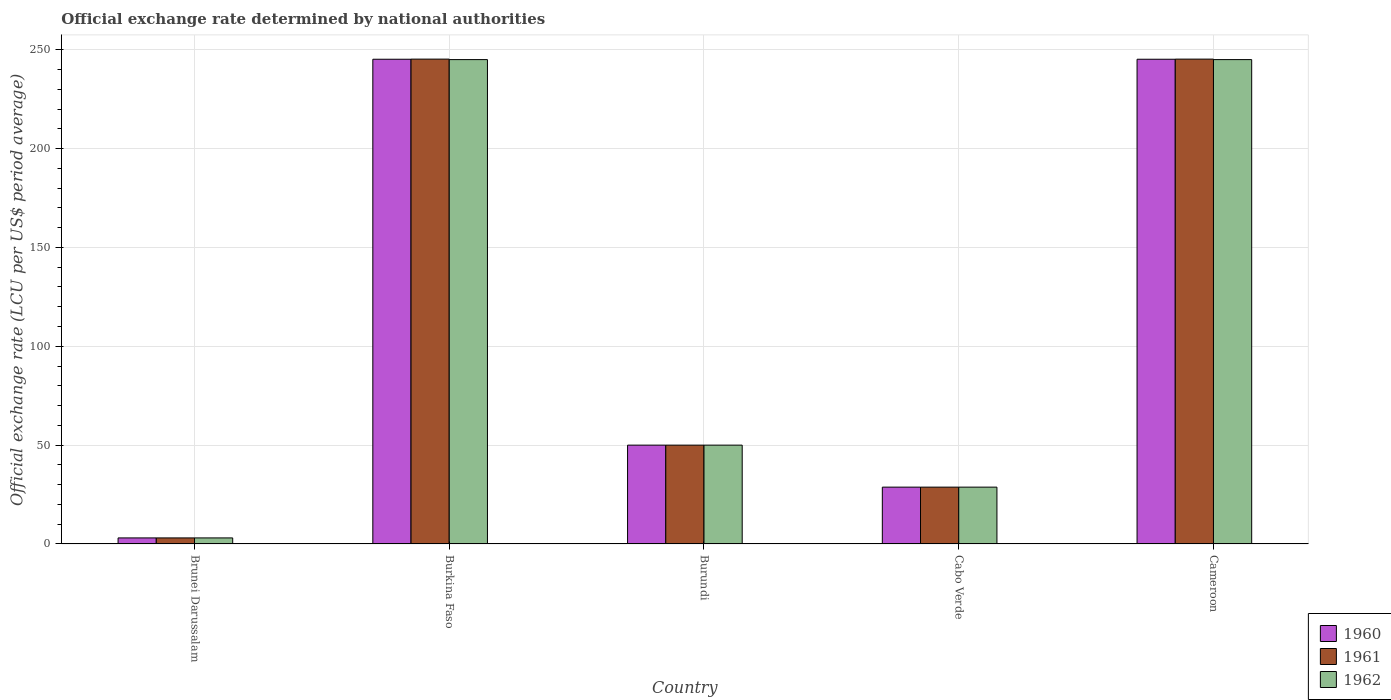How many different coloured bars are there?
Give a very brief answer. 3. How many bars are there on the 3rd tick from the left?
Your answer should be compact. 3. How many bars are there on the 4th tick from the right?
Your answer should be compact. 3. What is the label of the 1st group of bars from the left?
Make the answer very short. Brunei Darussalam. In how many cases, is the number of bars for a given country not equal to the number of legend labels?
Give a very brief answer. 0. What is the official exchange rate in 1960 in Cameroon?
Your answer should be compact. 245.2. Across all countries, what is the maximum official exchange rate in 1960?
Provide a succinct answer. 245.2. Across all countries, what is the minimum official exchange rate in 1962?
Your answer should be compact. 3.06. In which country was the official exchange rate in 1961 maximum?
Provide a succinct answer. Burkina Faso. In which country was the official exchange rate in 1960 minimum?
Provide a succinct answer. Brunei Darussalam. What is the total official exchange rate in 1961 in the graph?
Keep it short and to the point. 572.33. What is the difference between the official exchange rate in 1961 in Burkina Faso and that in Burundi?
Your response must be concise. 195.26. What is the difference between the official exchange rate in 1960 in Brunei Darussalam and the official exchange rate in 1962 in Cameroon?
Give a very brief answer. -241.95. What is the average official exchange rate in 1961 per country?
Make the answer very short. 114.47. What is the difference between the official exchange rate of/in 1961 and official exchange rate of/in 1960 in Burkina Faso?
Provide a succinct answer. 0.07. What is the ratio of the official exchange rate in 1960 in Burundi to that in Cabo Verde?
Your answer should be compact. 1.74. Is the official exchange rate in 1961 in Brunei Darussalam less than that in Cameroon?
Your response must be concise. Yes. What is the difference between the highest and the second highest official exchange rate in 1960?
Provide a succinct answer. -195.2. What is the difference between the highest and the lowest official exchange rate in 1961?
Your response must be concise. 242.2. In how many countries, is the official exchange rate in 1962 greater than the average official exchange rate in 1962 taken over all countries?
Make the answer very short. 2. Is the sum of the official exchange rate in 1962 in Brunei Darussalam and Cameroon greater than the maximum official exchange rate in 1960 across all countries?
Your answer should be very brief. Yes. What does the 1st bar from the left in Cabo Verde represents?
Keep it short and to the point. 1960. What does the 2nd bar from the right in Cameroon represents?
Ensure brevity in your answer.  1961. How many bars are there?
Keep it short and to the point. 15. Are all the bars in the graph horizontal?
Your answer should be compact. No. How many countries are there in the graph?
Offer a very short reply. 5. Are the values on the major ticks of Y-axis written in scientific E-notation?
Make the answer very short. No. Does the graph contain grids?
Your response must be concise. Yes. What is the title of the graph?
Keep it short and to the point. Official exchange rate determined by national authorities. Does "1996" appear as one of the legend labels in the graph?
Offer a terse response. No. What is the label or title of the Y-axis?
Keep it short and to the point. Official exchange rate (LCU per US$ period average). What is the Official exchange rate (LCU per US$ period average) in 1960 in Brunei Darussalam?
Provide a succinct answer. 3.06. What is the Official exchange rate (LCU per US$ period average) in 1961 in Brunei Darussalam?
Your answer should be compact. 3.06. What is the Official exchange rate (LCU per US$ period average) in 1962 in Brunei Darussalam?
Offer a terse response. 3.06. What is the Official exchange rate (LCU per US$ period average) in 1960 in Burkina Faso?
Keep it short and to the point. 245.2. What is the Official exchange rate (LCU per US$ period average) in 1961 in Burkina Faso?
Your answer should be very brief. 245.26. What is the Official exchange rate (LCU per US$ period average) in 1962 in Burkina Faso?
Offer a very short reply. 245.01. What is the Official exchange rate (LCU per US$ period average) of 1960 in Burundi?
Offer a very short reply. 50. What is the Official exchange rate (LCU per US$ period average) in 1961 in Burundi?
Your answer should be compact. 50. What is the Official exchange rate (LCU per US$ period average) of 1962 in Burundi?
Offer a very short reply. 50. What is the Official exchange rate (LCU per US$ period average) in 1960 in Cabo Verde?
Make the answer very short. 28.75. What is the Official exchange rate (LCU per US$ period average) in 1961 in Cabo Verde?
Your response must be concise. 28.75. What is the Official exchange rate (LCU per US$ period average) of 1962 in Cabo Verde?
Ensure brevity in your answer.  28.75. What is the Official exchange rate (LCU per US$ period average) in 1960 in Cameroon?
Make the answer very short. 245.2. What is the Official exchange rate (LCU per US$ period average) in 1961 in Cameroon?
Offer a very short reply. 245.26. What is the Official exchange rate (LCU per US$ period average) of 1962 in Cameroon?
Your response must be concise. 245.01. Across all countries, what is the maximum Official exchange rate (LCU per US$ period average) of 1960?
Make the answer very short. 245.2. Across all countries, what is the maximum Official exchange rate (LCU per US$ period average) in 1961?
Provide a short and direct response. 245.26. Across all countries, what is the maximum Official exchange rate (LCU per US$ period average) in 1962?
Provide a short and direct response. 245.01. Across all countries, what is the minimum Official exchange rate (LCU per US$ period average) in 1960?
Make the answer very short. 3.06. Across all countries, what is the minimum Official exchange rate (LCU per US$ period average) of 1961?
Offer a very short reply. 3.06. Across all countries, what is the minimum Official exchange rate (LCU per US$ period average) in 1962?
Provide a short and direct response. 3.06. What is the total Official exchange rate (LCU per US$ period average) in 1960 in the graph?
Keep it short and to the point. 572.2. What is the total Official exchange rate (LCU per US$ period average) of 1961 in the graph?
Ensure brevity in your answer.  572.33. What is the total Official exchange rate (LCU per US$ period average) of 1962 in the graph?
Offer a terse response. 571.84. What is the difference between the Official exchange rate (LCU per US$ period average) in 1960 in Brunei Darussalam and that in Burkina Faso?
Offer a very short reply. -242.13. What is the difference between the Official exchange rate (LCU per US$ period average) in 1961 in Brunei Darussalam and that in Burkina Faso?
Provide a succinct answer. -242.2. What is the difference between the Official exchange rate (LCU per US$ period average) in 1962 in Brunei Darussalam and that in Burkina Faso?
Your response must be concise. -241.95. What is the difference between the Official exchange rate (LCU per US$ period average) of 1960 in Brunei Darussalam and that in Burundi?
Ensure brevity in your answer.  -46.94. What is the difference between the Official exchange rate (LCU per US$ period average) in 1961 in Brunei Darussalam and that in Burundi?
Keep it short and to the point. -46.94. What is the difference between the Official exchange rate (LCU per US$ period average) of 1962 in Brunei Darussalam and that in Burundi?
Provide a succinct answer. -46.94. What is the difference between the Official exchange rate (LCU per US$ period average) of 1960 in Brunei Darussalam and that in Cabo Verde?
Provide a succinct answer. -25.69. What is the difference between the Official exchange rate (LCU per US$ period average) in 1961 in Brunei Darussalam and that in Cabo Verde?
Your answer should be compact. -25.69. What is the difference between the Official exchange rate (LCU per US$ period average) in 1962 in Brunei Darussalam and that in Cabo Verde?
Ensure brevity in your answer.  -25.69. What is the difference between the Official exchange rate (LCU per US$ period average) of 1960 in Brunei Darussalam and that in Cameroon?
Your answer should be compact. -242.13. What is the difference between the Official exchange rate (LCU per US$ period average) of 1961 in Brunei Darussalam and that in Cameroon?
Make the answer very short. -242.2. What is the difference between the Official exchange rate (LCU per US$ period average) in 1962 in Brunei Darussalam and that in Cameroon?
Your answer should be very brief. -241.95. What is the difference between the Official exchange rate (LCU per US$ period average) in 1960 in Burkina Faso and that in Burundi?
Provide a succinct answer. 195.2. What is the difference between the Official exchange rate (LCU per US$ period average) in 1961 in Burkina Faso and that in Burundi?
Ensure brevity in your answer.  195.26. What is the difference between the Official exchange rate (LCU per US$ period average) in 1962 in Burkina Faso and that in Burundi?
Make the answer very short. 195.01. What is the difference between the Official exchange rate (LCU per US$ period average) of 1960 in Burkina Faso and that in Cabo Verde?
Ensure brevity in your answer.  216.45. What is the difference between the Official exchange rate (LCU per US$ period average) of 1961 in Burkina Faso and that in Cabo Verde?
Keep it short and to the point. 216.51. What is the difference between the Official exchange rate (LCU per US$ period average) in 1962 in Burkina Faso and that in Cabo Verde?
Offer a terse response. 216.26. What is the difference between the Official exchange rate (LCU per US$ period average) in 1961 in Burkina Faso and that in Cameroon?
Offer a very short reply. 0. What is the difference between the Official exchange rate (LCU per US$ period average) of 1962 in Burkina Faso and that in Cameroon?
Keep it short and to the point. 0. What is the difference between the Official exchange rate (LCU per US$ period average) of 1960 in Burundi and that in Cabo Verde?
Your response must be concise. 21.25. What is the difference between the Official exchange rate (LCU per US$ period average) in 1961 in Burundi and that in Cabo Verde?
Provide a short and direct response. 21.25. What is the difference between the Official exchange rate (LCU per US$ period average) of 1962 in Burundi and that in Cabo Verde?
Give a very brief answer. 21.25. What is the difference between the Official exchange rate (LCU per US$ period average) of 1960 in Burundi and that in Cameroon?
Provide a short and direct response. -195.2. What is the difference between the Official exchange rate (LCU per US$ period average) in 1961 in Burundi and that in Cameroon?
Make the answer very short. -195.26. What is the difference between the Official exchange rate (LCU per US$ period average) of 1962 in Burundi and that in Cameroon?
Offer a very short reply. -195.01. What is the difference between the Official exchange rate (LCU per US$ period average) in 1960 in Cabo Verde and that in Cameroon?
Your response must be concise. -216.45. What is the difference between the Official exchange rate (LCU per US$ period average) in 1961 in Cabo Verde and that in Cameroon?
Provide a succinct answer. -216.51. What is the difference between the Official exchange rate (LCU per US$ period average) of 1962 in Cabo Verde and that in Cameroon?
Your response must be concise. -216.26. What is the difference between the Official exchange rate (LCU per US$ period average) of 1960 in Brunei Darussalam and the Official exchange rate (LCU per US$ period average) of 1961 in Burkina Faso?
Offer a terse response. -242.2. What is the difference between the Official exchange rate (LCU per US$ period average) in 1960 in Brunei Darussalam and the Official exchange rate (LCU per US$ period average) in 1962 in Burkina Faso?
Provide a short and direct response. -241.95. What is the difference between the Official exchange rate (LCU per US$ period average) in 1961 in Brunei Darussalam and the Official exchange rate (LCU per US$ period average) in 1962 in Burkina Faso?
Keep it short and to the point. -241.95. What is the difference between the Official exchange rate (LCU per US$ period average) in 1960 in Brunei Darussalam and the Official exchange rate (LCU per US$ period average) in 1961 in Burundi?
Your response must be concise. -46.94. What is the difference between the Official exchange rate (LCU per US$ period average) of 1960 in Brunei Darussalam and the Official exchange rate (LCU per US$ period average) of 1962 in Burundi?
Ensure brevity in your answer.  -46.94. What is the difference between the Official exchange rate (LCU per US$ period average) of 1961 in Brunei Darussalam and the Official exchange rate (LCU per US$ period average) of 1962 in Burundi?
Your answer should be very brief. -46.94. What is the difference between the Official exchange rate (LCU per US$ period average) of 1960 in Brunei Darussalam and the Official exchange rate (LCU per US$ period average) of 1961 in Cabo Verde?
Offer a very short reply. -25.69. What is the difference between the Official exchange rate (LCU per US$ period average) of 1960 in Brunei Darussalam and the Official exchange rate (LCU per US$ period average) of 1962 in Cabo Verde?
Keep it short and to the point. -25.69. What is the difference between the Official exchange rate (LCU per US$ period average) in 1961 in Brunei Darussalam and the Official exchange rate (LCU per US$ period average) in 1962 in Cabo Verde?
Offer a very short reply. -25.69. What is the difference between the Official exchange rate (LCU per US$ period average) in 1960 in Brunei Darussalam and the Official exchange rate (LCU per US$ period average) in 1961 in Cameroon?
Provide a short and direct response. -242.2. What is the difference between the Official exchange rate (LCU per US$ period average) of 1960 in Brunei Darussalam and the Official exchange rate (LCU per US$ period average) of 1962 in Cameroon?
Provide a succinct answer. -241.95. What is the difference between the Official exchange rate (LCU per US$ period average) of 1961 in Brunei Darussalam and the Official exchange rate (LCU per US$ period average) of 1962 in Cameroon?
Make the answer very short. -241.95. What is the difference between the Official exchange rate (LCU per US$ period average) in 1960 in Burkina Faso and the Official exchange rate (LCU per US$ period average) in 1961 in Burundi?
Your answer should be compact. 195.2. What is the difference between the Official exchange rate (LCU per US$ period average) in 1960 in Burkina Faso and the Official exchange rate (LCU per US$ period average) in 1962 in Burundi?
Provide a short and direct response. 195.2. What is the difference between the Official exchange rate (LCU per US$ period average) in 1961 in Burkina Faso and the Official exchange rate (LCU per US$ period average) in 1962 in Burundi?
Offer a terse response. 195.26. What is the difference between the Official exchange rate (LCU per US$ period average) in 1960 in Burkina Faso and the Official exchange rate (LCU per US$ period average) in 1961 in Cabo Verde?
Your answer should be compact. 216.45. What is the difference between the Official exchange rate (LCU per US$ period average) of 1960 in Burkina Faso and the Official exchange rate (LCU per US$ period average) of 1962 in Cabo Verde?
Your response must be concise. 216.45. What is the difference between the Official exchange rate (LCU per US$ period average) in 1961 in Burkina Faso and the Official exchange rate (LCU per US$ period average) in 1962 in Cabo Verde?
Your answer should be very brief. 216.51. What is the difference between the Official exchange rate (LCU per US$ period average) of 1960 in Burkina Faso and the Official exchange rate (LCU per US$ period average) of 1961 in Cameroon?
Ensure brevity in your answer.  -0.07. What is the difference between the Official exchange rate (LCU per US$ period average) of 1960 in Burkina Faso and the Official exchange rate (LCU per US$ period average) of 1962 in Cameroon?
Offer a terse response. 0.18. What is the difference between the Official exchange rate (LCU per US$ period average) in 1961 in Burkina Faso and the Official exchange rate (LCU per US$ period average) in 1962 in Cameroon?
Offer a very short reply. 0.25. What is the difference between the Official exchange rate (LCU per US$ period average) of 1960 in Burundi and the Official exchange rate (LCU per US$ period average) of 1961 in Cabo Verde?
Give a very brief answer. 21.25. What is the difference between the Official exchange rate (LCU per US$ period average) of 1960 in Burundi and the Official exchange rate (LCU per US$ period average) of 1962 in Cabo Verde?
Offer a terse response. 21.25. What is the difference between the Official exchange rate (LCU per US$ period average) in 1961 in Burundi and the Official exchange rate (LCU per US$ period average) in 1962 in Cabo Verde?
Provide a short and direct response. 21.25. What is the difference between the Official exchange rate (LCU per US$ period average) in 1960 in Burundi and the Official exchange rate (LCU per US$ period average) in 1961 in Cameroon?
Keep it short and to the point. -195.26. What is the difference between the Official exchange rate (LCU per US$ period average) in 1960 in Burundi and the Official exchange rate (LCU per US$ period average) in 1962 in Cameroon?
Offer a very short reply. -195.01. What is the difference between the Official exchange rate (LCU per US$ period average) in 1961 in Burundi and the Official exchange rate (LCU per US$ period average) in 1962 in Cameroon?
Make the answer very short. -195.01. What is the difference between the Official exchange rate (LCU per US$ period average) in 1960 in Cabo Verde and the Official exchange rate (LCU per US$ period average) in 1961 in Cameroon?
Your answer should be compact. -216.51. What is the difference between the Official exchange rate (LCU per US$ period average) of 1960 in Cabo Verde and the Official exchange rate (LCU per US$ period average) of 1962 in Cameroon?
Provide a short and direct response. -216.26. What is the difference between the Official exchange rate (LCU per US$ period average) in 1961 in Cabo Verde and the Official exchange rate (LCU per US$ period average) in 1962 in Cameroon?
Provide a short and direct response. -216.26. What is the average Official exchange rate (LCU per US$ period average) in 1960 per country?
Make the answer very short. 114.44. What is the average Official exchange rate (LCU per US$ period average) of 1961 per country?
Provide a short and direct response. 114.47. What is the average Official exchange rate (LCU per US$ period average) of 1962 per country?
Give a very brief answer. 114.37. What is the difference between the Official exchange rate (LCU per US$ period average) in 1960 and Official exchange rate (LCU per US$ period average) in 1961 in Brunei Darussalam?
Offer a terse response. 0. What is the difference between the Official exchange rate (LCU per US$ period average) of 1960 and Official exchange rate (LCU per US$ period average) of 1962 in Brunei Darussalam?
Offer a very short reply. 0. What is the difference between the Official exchange rate (LCU per US$ period average) of 1961 and Official exchange rate (LCU per US$ period average) of 1962 in Brunei Darussalam?
Give a very brief answer. 0. What is the difference between the Official exchange rate (LCU per US$ period average) in 1960 and Official exchange rate (LCU per US$ period average) in 1961 in Burkina Faso?
Provide a succinct answer. -0.07. What is the difference between the Official exchange rate (LCU per US$ period average) in 1960 and Official exchange rate (LCU per US$ period average) in 1962 in Burkina Faso?
Your answer should be compact. 0.18. What is the difference between the Official exchange rate (LCU per US$ period average) of 1961 and Official exchange rate (LCU per US$ period average) of 1962 in Burkina Faso?
Keep it short and to the point. 0.25. What is the difference between the Official exchange rate (LCU per US$ period average) in 1960 and Official exchange rate (LCU per US$ period average) in 1961 in Burundi?
Offer a very short reply. 0. What is the difference between the Official exchange rate (LCU per US$ period average) in 1960 and Official exchange rate (LCU per US$ period average) in 1962 in Burundi?
Offer a very short reply. 0. What is the difference between the Official exchange rate (LCU per US$ period average) in 1961 and Official exchange rate (LCU per US$ period average) in 1962 in Burundi?
Ensure brevity in your answer.  0. What is the difference between the Official exchange rate (LCU per US$ period average) in 1960 and Official exchange rate (LCU per US$ period average) in 1961 in Cabo Verde?
Offer a terse response. 0. What is the difference between the Official exchange rate (LCU per US$ period average) of 1960 and Official exchange rate (LCU per US$ period average) of 1961 in Cameroon?
Offer a very short reply. -0.07. What is the difference between the Official exchange rate (LCU per US$ period average) of 1960 and Official exchange rate (LCU per US$ period average) of 1962 in Cameroon?
Your answer should be very brief. 0.18. What is the difference between the Official exchange rate (LCU per US$ period average) of 1961 and Official exchange rate (LCU per US$ period average) of 1962 in Cameroon?
Offer a terse response. 0.25. What is the ratio of the Official exchange rate (LCU per US$ period average) in 1960 in Brunei Darussalam to that in Burkina Faso?
Keep it short and to the point. 0.01. What is the ratio of the Official exchange rate (LCU per US$ period average) of 1961 in Brunei Darussalam to that in Burkina Faso?
Offer a terse response. 0.01. What is the ratio of the Official exchange rate (LCU per US$ period average) in 1962 in Brunei Darussalam to that in Burkina Faso?
Provide a succinct answer. 0.01. What is the ratio of the Official exchange rate (LCU per US$ period average) in 1960 in Brunei Darussalam to that in Burundi?
Give a very brief answer. 0.06. What is the ratio of the Official exchange rate (LCU per US$ period average) of 1961 in Brunei Darussalam to that in Burundi?
Ensure brevity in your answer.  0.06. What is the ratio of the Official exchange rate (LCU per US$ period average) in 1962 in Brunei Darussalam to that in Burundi?
Offer a terse response. 0.06. What is the ratio of the Official exchange rate (LCU per US$ period average) in 1960 in Brunei Darussalam to that in Cabo Verde?
Offer a terse response. 0.11. What is the ratio of the Official exchange rate (LCU per US$ period average) of 1961 in Brunei Darussalam to that in Cabo Verde?
Provide a short and direct response. 0.11. What is the ratio of the Official exchange rate (LCU per US$ period average) in 1962 in Brunei Darussalam to that in Cabo Verde?
Offer a terse response. 0.11. What is the ratio of the Official exchange rate (LCU per US$ period average) of 1960 in Brunei Darussalam to that in Cameroon?
Make the answer very short. 0.01. What is the ratio of the Official exchange rate (LCU per US$ period average) of 1961 in Brunei Darussalam to that in Cameroon?
Make the answer very short. 0.01. What is the ratio of the Official exchange rate (LCU per US$ period average) in 1962 in Brunei Darussalam to that in Cameroon?
Offer a very short reply. 0.01. What is the ratio of the Official exchange rate (LCU per US$ period average) in 1960 in Burkina Faso to that in Burundi?
Give a very brief answer. 4.9. What is the ratio of the Official exchange rate (LCU per US$ period average) of 1961 in Burkina Faso to that in Burundi?
Give a very brief answer. 4.91. What is the ratio of the Official exchange rate (LCU per US$ period average) in 1962 in Burkina Faso to that in Burundi?
Ensure brevity in your answer.  4.9. What is the ratio of the Official exchange rate (LCU per US$ period average) in 1960 in Burkina Faso to that in Cabo Verde?
Your response must be concise. 8.53. What is the ratio of the Official exchange rate (LCU per US$ period average) in 1961 in Burkina Faso to that in Cabo Verde?
Provide a succinct answer. 8.53. What is the ratio of the Official exchange rate (LCU per US$ period average) of 1962 in Burkina Faso to that in Cabo Verde?
Give a very brief answer. 8.52. What is the ratio of the Official exchange rate (LCU per US$ period average) in 1960 in Burkina Faso to that in Cameroon?
Make the answer very short. 1. What is the ratio of the Official exchange rate (LCU per US$ period average) in 1960 in Burundi to that in Cabo Verde?
Keep it short and to the point. 1.74. What is the ratio of the Official exchange rate (LCU per US$ period average) in 1961 in Burundi to that in Cabo Verde?
Offer a very short reply. 1.74. What is the ratio of the Official exchange rate (LCU per US$ period average) of 1962 in Burundi to that in Cabo Verde?
Your answer should be very brief. 1.74. What is the ratio of the Official exchange rate (LCU per US$ period average) of 1960 in Burundi to that in Cameroon?
Your answer should be compact. 0.2. What is the ratio of the Official exchange rate (LCU per US$ period average) of 1961 in Burundi to that in Cameroon?
Provide a short and direct response. 0.2. What is the ratio of the Official exchange rate (LCU per US$ period average) in 1962 in Burundi to that in Cameroon?
Your answer should be very brief. 0.2. What is the ratio of the Official exchange rate (LCU per US$ period average) in 1960 in Cabo Verde to that in Cameroon?
Provide a short and direct response. 0.12. What is the ratio of the Official exchange rate (LCU per US$ period average) of 1961 in Cabo Verde to that in Cameroon?
Provide a short and direct response. 0.12. What is the ratio of the Official exchange rate (LCU per US$ period average) of 1962 in Cabo Verde to that in Cameroon?
Ensure brevity in your answer.  0.12. What is the difference between the highest and the second highest Official exchange rate (LCU per US$ period average) in 1962?
Your response must be concise. 0. What is the difference between the highest and the lowest Official exchange rate (LCU per US$ period average) in 1960?
Ensure brevity in your answer.  242.13. What is the difference between the highest and the lowest Official exchange rate (LCU per US$ period average) in 1961?
Your answer should be compact. 242.2. What is the difference between the highest and the lowest Official exchange rate (LCU per US$ period average) of 1962?
Provide a short and direct response. 241.95. 